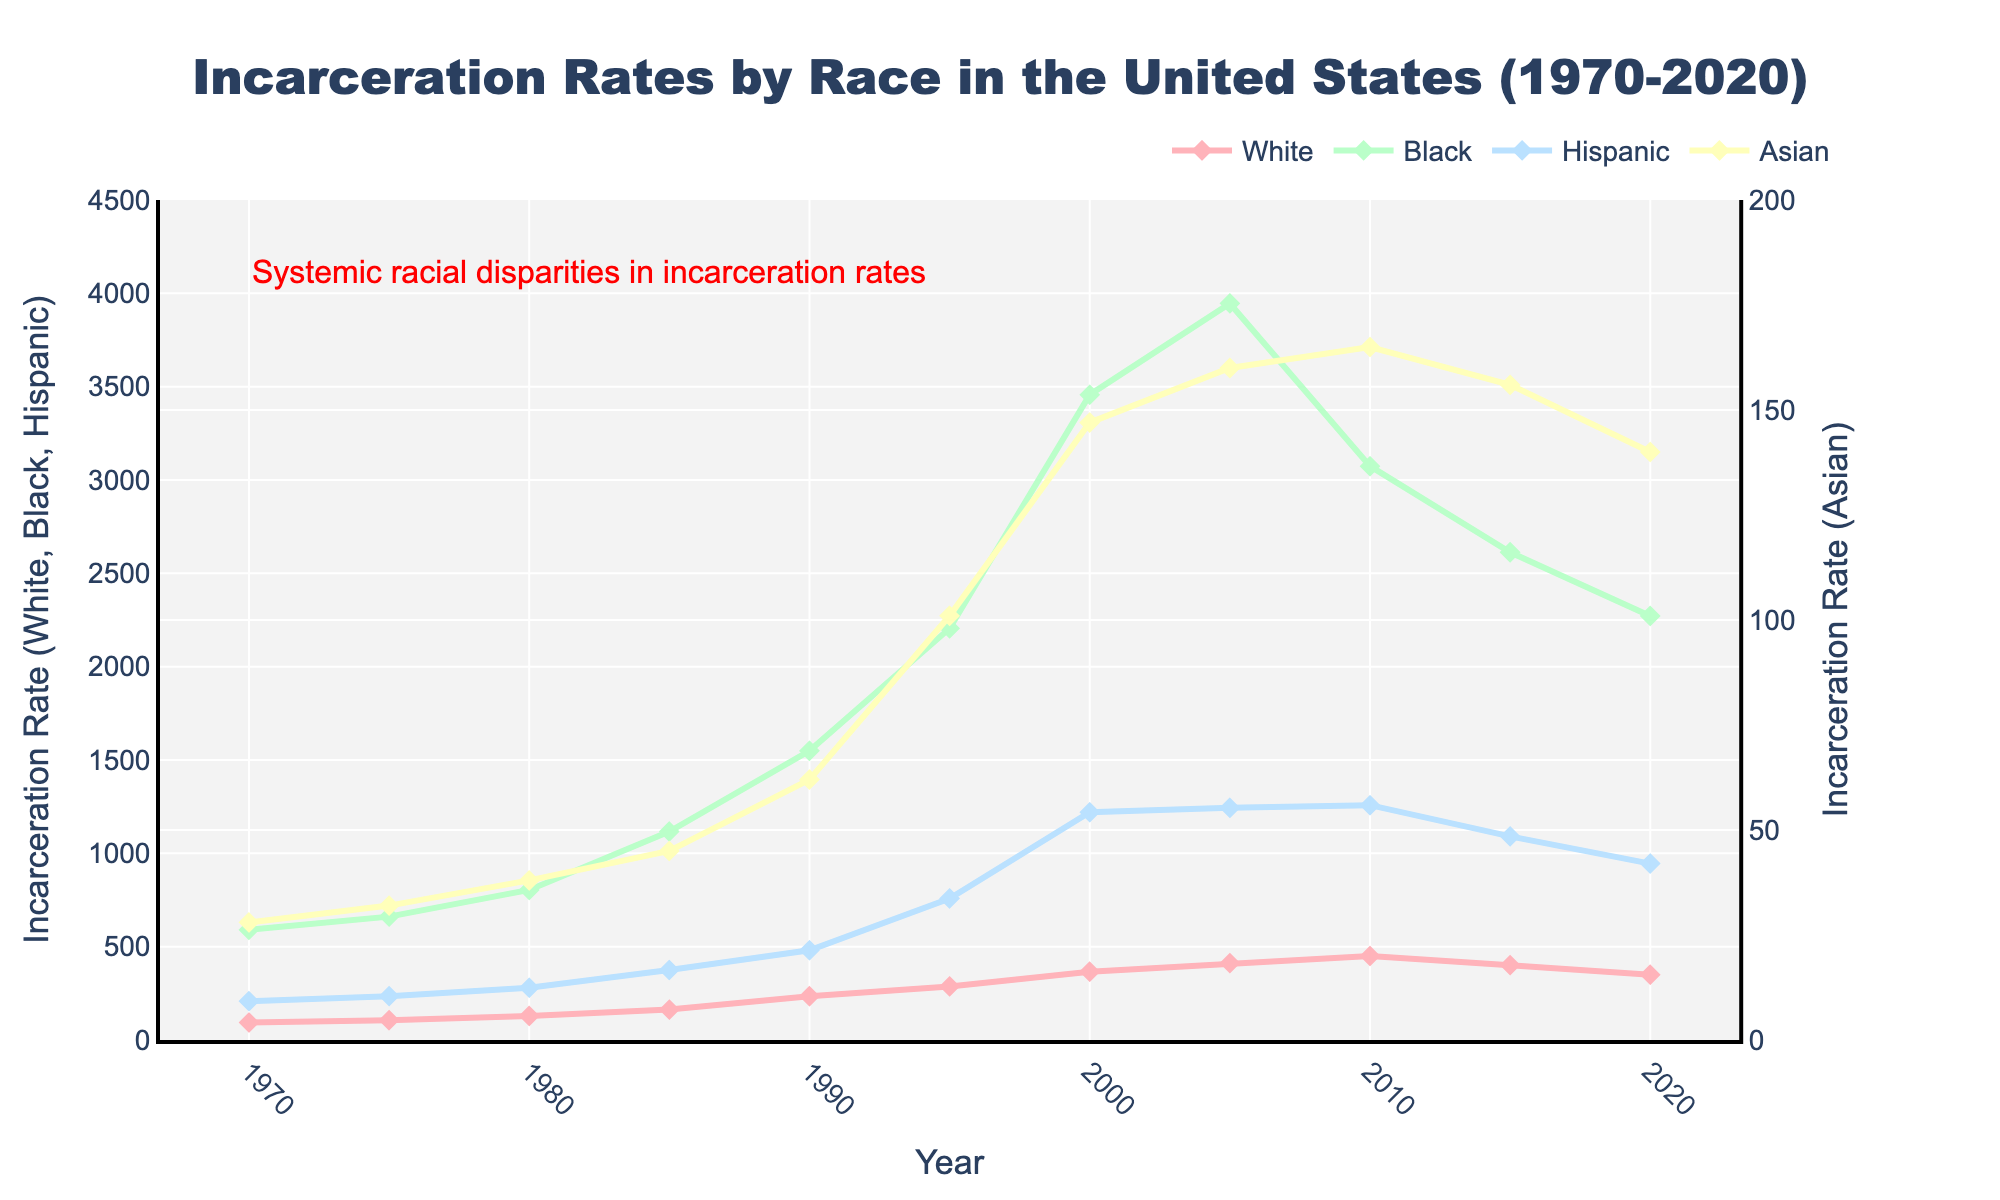When did incarceration rates for Black individuals peak, and what was the rate? The incarceration rates for Black individuals peaked between 1995 and 2000. By analyzing this period, the highest rate was approximately in 2000 with a rate of 3457 per 100,000.
Answer: 2000, 3457 Which racial group had the lowest incarceration rate in 1980, and what was the rate? In 1980, by examining the figure, the Asian group had the lowest incarceration rate, which was 38 per 100,000.
Answer: Asian, 38 What was the difference in incarceration rates between Black and White individuals in 1990? To find the difference, subtract the incarceration rate of White individuals from that of Black individuals in 1990. The rates are 1549 for Black individuals and 235 for White individuals, so the difference is 1549 - 235 = 1314.
Answer: 1314 From 1970 to 2020, which racial group saw the highest increase in incarceration rates, and by how much did it increase? To find this, identify the group with the highest increase by comparing the initial and final values. For Black individuals, the rate increased from 590 (1970) to 2272 (2020), which is an increase of 1682. For other groups, the increases are smaller: White (256), Hispanic (737), and Asian (112).
Answer: Black, 1682 How many years did it take for the Hispanic incarceration rate to cross 1000 per 100,000 for the first time? By examining the figure, the Hispanic incarceration rate crossed 1000 per 100,000 in the period between 1990 and 1995. It was 758 in 1995, so it first crossed 1000 in the year 2000 with a rate of 1220. Counting from 1970 to 2000, it took 30 years.
Answer: 30 years Compare the trend of incarceration rates for Hispanics and Asians from 2000 to 2020. From 2000 to 2020, the Hispanic incarceration rate shows a declining trend, decreasing from 1220 to 945. Similarly, the Asian incarceration rate also decreases marginally from 147 to 140. Both groups exhibit downward trends during this period.
Answer: Both downward What is the average incarceration rate for White individuals across the span of 50 years (1970–2020)? Calculate the average by summing up the White incarceration rates and dividing by the number of years. The sum of the rates is 94 + 106 + 129 + 163 + 235 + 287 + 366 + 412 + 450 + 401 + 350 = 2993. Dividing by the number of years, 2993 / 11 ~ 272.
Answer: 272 Which groups' incarceration rates showed a decline from 2010 to 2020, and by how much? The groups whose rates declined from 2010 to 2020 are Black, Hispanic, and Asian. Calculate the decrease: Black (3074 to 2272, decrease by 802), Hispanic (1258 to 945, decrease by 313), Asian (165 to 140, decrease by 25).
Answer: Black, Hispanic, Asian; 802, 313, 25 